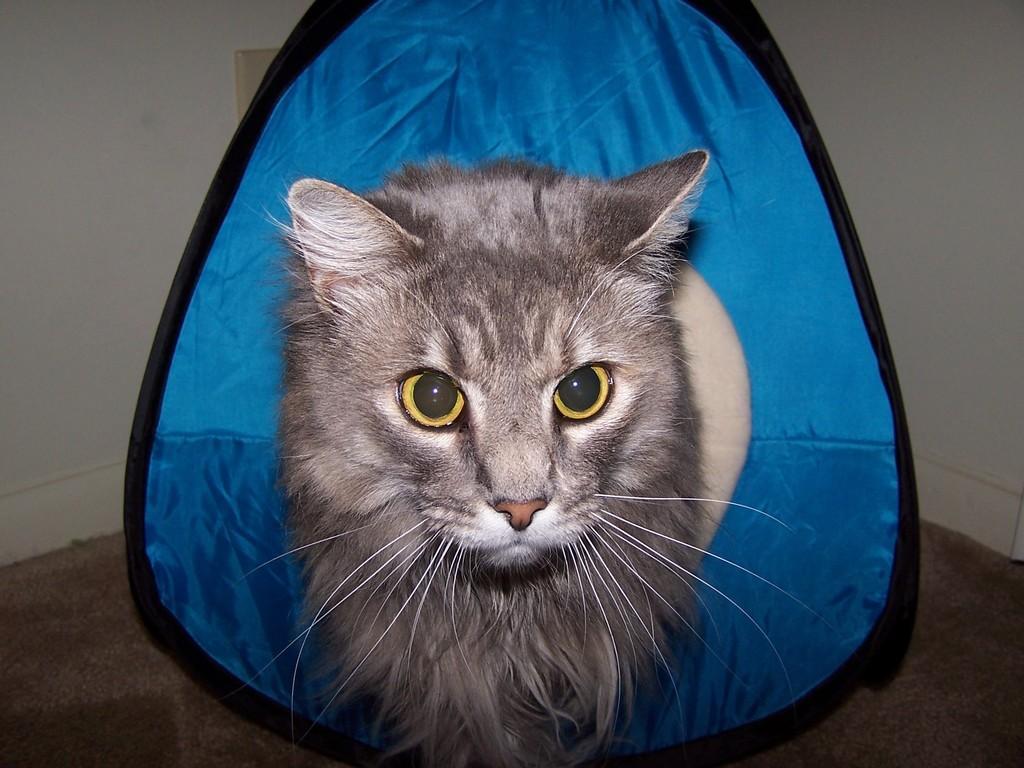Can you describe this image briefly? In this image I can see there is a cat and in the background there is a blue color object. 